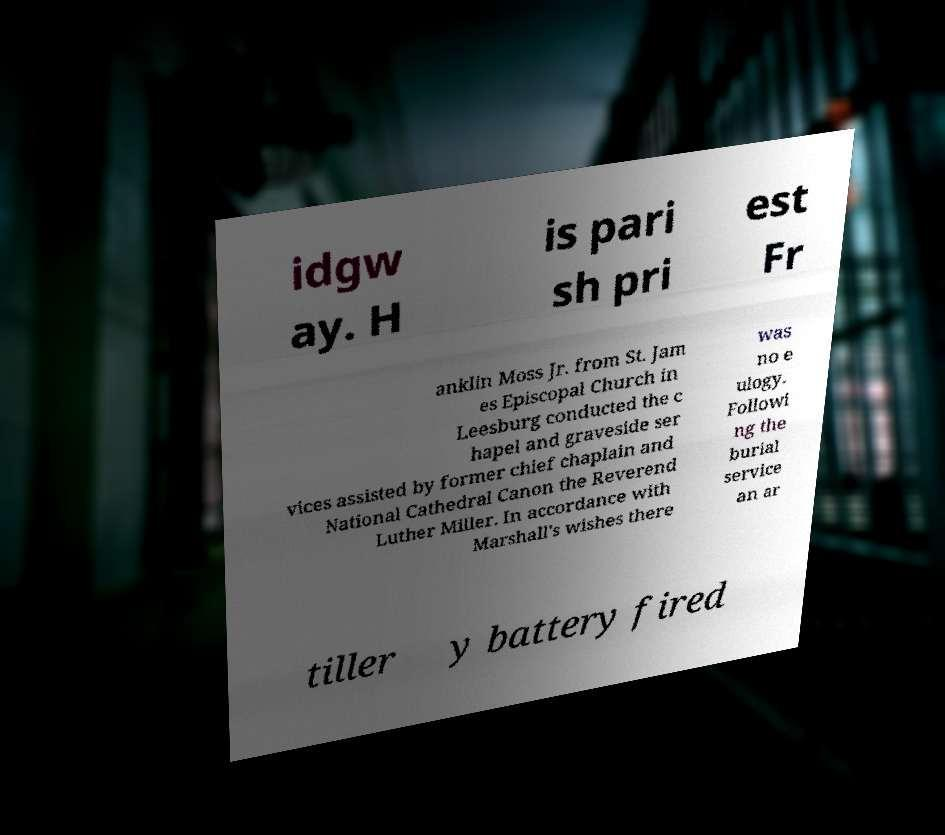There's text embedded in this image that I need extracted. Can you transcribe it verbatim? idgw ay. H is pari sh pri est Fr anklin Moss Jr. from St. Jam es Episcopal Church in Leesburg conducted the c hapel and graveside ser vices assisted by former chief chaplain and National Cathedral Canon the Reverend Luther Miller. In accordance with Marshall's wishes there was no e ulogy. Followi ng the burial service an ar tiller y battery fired 